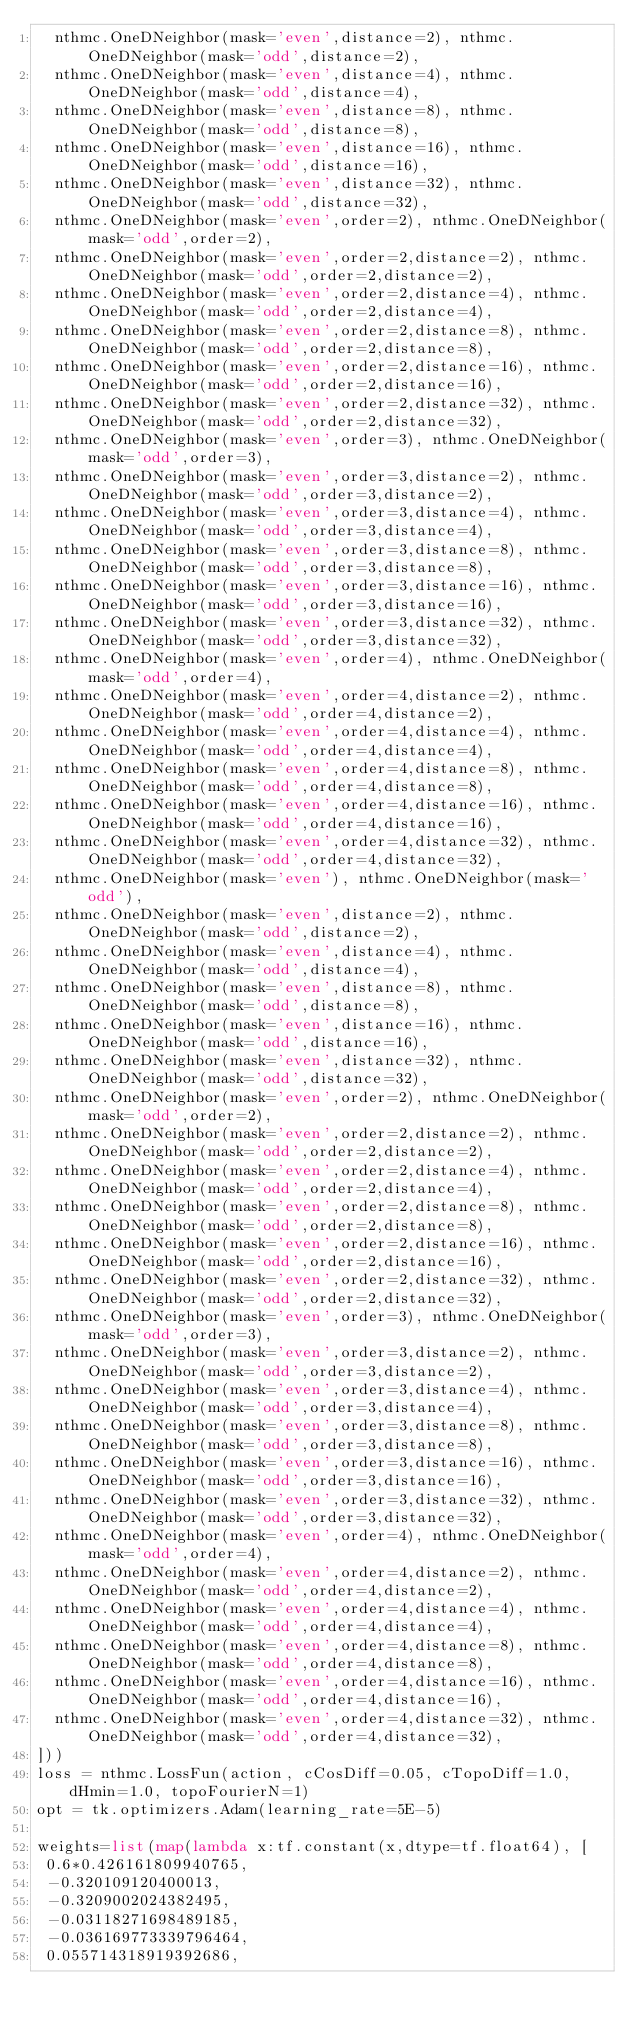Convert code to text. <code><loc_0><loc_0><loc_500><loc_500><_Python_>  nthmc.OneDNeighbor(mask='even',distance=2), nthmc.OneDNeighbor(mask='odd',distance=2),
  nthmc.OneDNeighbor(mask='even',distance=4), nthmc.OneDNeighbor(mask='odd',distance=4),
  nthmc.OneDNeighbor(mask='even',distance=8), nthmc.OneDNeighbor(mask='odd',distance=8),
  nthmc.OneDNeighbor(mask='even',distance=16), nthmc.OneDNeighbor(mask='odd',distance=16),
  nthmc.OneDNeighbor(mask='even',distance=32), nthmc.OneDNeighbor(mask='odd',distance=32),
  nthmc.OneDNeighbor(mask='even',order=2), nthmc.OneDNeighbor(mask='odd',order=2),
  nthmc.OneDNeighbor(mask='even',order=2,distance=2), nthmc.OneDNeighbor(mask='odd',order=2,distance=2),
  nthmc.OneDNeighbor(mask='even',order=2,distance=4), nthmc.OneDNeighbor(mask='odd',order=2,distance=4),
  nthmc.OneDNeighbor(mask='even',order=2,distance=8), nthmc.OneDNeighbor(mask='odd',order=2,distance=8),
  nthmc.OneDNeighbor(mask='even',order=2,distance=16), nthmc.OneDNeighbor(mask='odd',order=2,distance=16),
  nthmc.OneDNeighbor(mask='even',order=2,distance=32), nthmc.OneDNeighbor(mask='odd',order=2,distance=32),
  nthmc.OneDNeighbor(mask='even',order=3), nthmc.OneDNeighbor(mask='odd',order=3),
  nthmc.OneDNeighbor(mask='even',order=3,distance=2), nthmc.OneDNeighbor(mask='odd',order=3,distance=2),
  nthmc.OneDNeighbor(mask='even',order=3,distance=4), nthmc.OneDNeighbor(mask='odd',order=3,distance=4),
  nthmc.OneDNeighbor(mask='even',order=3,distance=8), nthmc.OneDNeighbor(mask='odd',order=3,distance=8),
  nthmc.OneDNeighbor(mask='even',order=3,distance=16), nthmc.OneDNeighbor(mask='odd',order=3,distance=16),
  nthmc.OneDNeighbor(mask='even',order=3,distance=32), nthmc.OneDNeighbor(mask='odd',order=3,distance=32),
  nthmc.OneDNeighbor(mask='even',order=4), nthmc.OneDNeighbor(mask='odd',order=4),
  nthmc.OneDNeighbor(mask='even',order=4,distance=2), nthmc.OneDNeighbor(mask='odd',order=4,distance=2),
  nthmc.OneDNeighbor(mask='even',order=4,distance=4), nthmc.OneDNeighbor(mask='odd',order=4,distance=4),
  nthmc.OneDNeighbor(mask='even',order=4,distance=8), nthmc.OneDNeighbor(mask='odd',order=4,distance=8),
  nthmc.OneDNeighbor(mask='even',order=4,distance=16), nthmc.OneDNeighbor(mask='odd',order=4,distance=16),
  nthmc.OneDNeighbor(mask='even',order=4,distance=32), nthmc.OneDNeighbor(mask='odd',order=4,distance=32),
  nthmc.OneDNeighbor(mask='even'), nthmc.OneDNeighbor(mask='odd'),
  nthmc.OneDNeighbor(mask='even',distance=2), nthmc.OneDNeighbor(mask='odd',distance=2),
  nthmc.OneDNeighbor(mask='even',distance=4), nthmc.OneDNeighbor(mask='odd',distance=4),
  nthmc.OneDNeighbor(mask='even',distance=8), nthmc.OneDNeighbor(mask='odd',distance=8),
  nthmc.OneDNeighbor(mask='even',distance=16), nthmc.OneDNeighbor(mask='odd',distance=16),
  nthmc.OneDNeighbor(mask='even',distance=32), nthmc.OneDNeighbor(mask='odd',distance=32),
  nthmc.OneDNeighbor(mask='even',order=2), nthmc.OneDNeighbor(mask='odd',order=2),
  nthmc.OneDNeighbor(mask='even',order=2,distance=2), nthmc.OneDNeighbor(mask='odd',order=2,distance=2),
  nthmc.OneDNeighbor(mask='even',order=2,distance=4), nthmc.OneDNeighbor(mask='odd',order=2,distance=4),
  nthmc.OneDNeighbor(mask='even',order=2,distance=8), nthmc.OneDNeighbor(mask='odd',order=2,distance=8),
  nthmc.OneDNeighbor(mask='even',order=2,distance=16), nthmc.OneDNeighbor(mask='odd',order=2,distance=16),
  nthmc.OneDNeighbor(mask='even',order=2,distance=32), nthmc.OneDNeighbor(mask='odd',order=2,distance=32),
  nthmc.OneDNeighbor(mask='even',order=3), nthmc.OneDNeighbor(mask='odd',order=3),
  nthmc.OneDNeighbor(mask='even',order=3,distance=2), nthmc.OneDNeighbor(mask='odd',order=3,distance=2),
  nthmc.OneDNeighbor(mask='even',order=3,distance=4), nthmc.OneDNeighbor(mask='odd',order=3,distance=4),
  nthmc.OneDNeighbor(mask='even',order=3,distance=8), nthmc.OneDNeighbor(mask='odd',order=3,distance=8),
  nthmc.OneDNeighbor(mask='even',order=3,distance=16), nthmc.OneDNeighbor(mask='odd',order=3,distance=16),
  nthmc.OneDNeighbor(mask='even',order=3,distance=32), nthmc.OneDNeighbor(mask='odd',order=3,distance=32),
  nthmc.OneDNeighbor(mask='even',order=4), nthmc.OneDNeighbor(mask='odd',order=4),
  nthmc.OneDNeighbor(mask='even',order=4,distance=2), nthmc.OneDNeighbor(mask='odd',order=4,distance=2),
  nthmc.OneDNeighbor(mask='even',order=4,distance=4), nthmc.OneDNeighbor(mask='odd',order=4,distance=4),
  nthmc.OneDNeighbor(mask='even',order=4,distance=8), nthmc.OneDNeighbor(mask='odd',order=4,distance=8),
  nthmc.OneDNeighbor(mask='even',order=4,distance=16), nthmc.OneDNeighbor(mask='odd',order=4,distance=16),
  nthmc.OneDNeighbor(mask='even',order=4,distance=32), nthmc.OneDNeighbor(mask='odd',order=4,distance=32),
]))
loss = nthmc.LossFun(action, cCosDiff=0.05, cTopoDiff=1.0, dHmin=1.0, topoFourierN=1)
opt = tk.optimizers.Adam(learning_rate=5E-5)

weights=list(map(lambda x:tf.constant(x,dtype=tf.float64), [
 0.6*0.426161809940765,
 -0.320109120400013,
 -0.3209002024382495,
 -0.03118271698489185,
 -0.036169773339796464,
 0.055714318919392686,</code> 